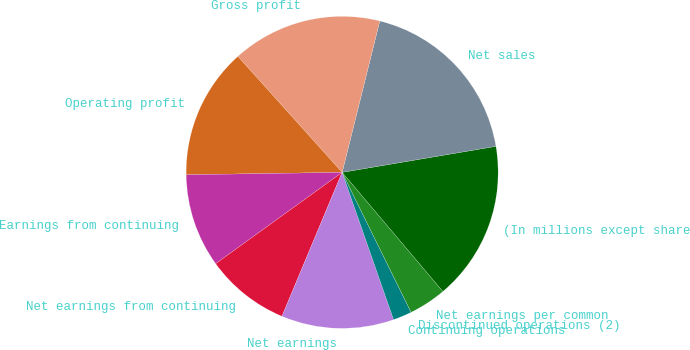Convert chart. <chart><loc_0><loc_0><loc_500><loc_500><pie_chart><fcel>(In millions except share<fcel>Net sales<fcel>Gross profit<fcel>Operating profit<fcel>Earnings from continuing<fcel>Net earnings from continuing<fcel>Net earnings<fcel>Continuing operations<fcel>Discontinued operations (2)<fcel>Net earnings per common<nl><fcel>16.5%<fcel>18.45%<fcel>15.53%<fcel>13.59%<fcel>9.71%<fcel>8.74%<fcel>11.65%<fcel>1.94%<fcel>0.0%<fcel>3.88%<nl></chart> 